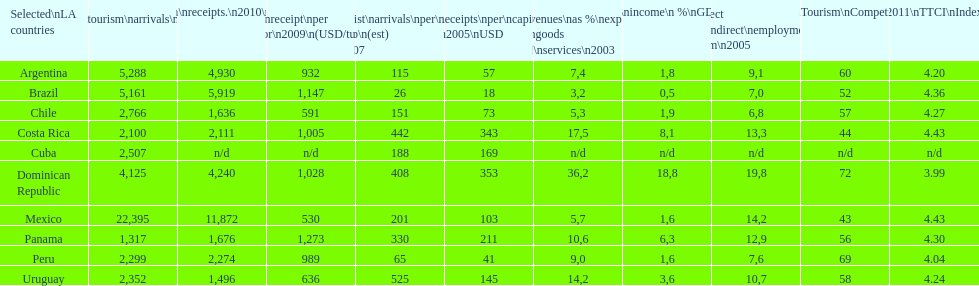Would you mind parsing the complete table? {'header': ['Selected\\nLA countries', 'Internl.\\ntourism\\narrivals\\n2010\\n(x 1000)', 'Internl.\\ntourism\\nreceipts.\\n2010\\n(USD\\n(x1000)', 'Avg\\nreceipt\\nper visitor\\n2009\\n(USD/turista)', 'Tourist\\narrivals\\nper\\n1000 inhab\\n(est) \\n2007', 'Receipts\\nper\\ncapita \\n2005\\nUSD', 'Revenues\\nas\xa0%\\nexports of\\ngoods and\\nservices\\n2003', 'Tourism\\nincome\\n\xa0%\\nGDP\\n2003', '% Direct and\\nindirect\\nemployment\\nin tourism\\n2005', 'World\\nranking\\nTourism\\nCompetitiv.\\nTTCI\\n2011', '2011\\nTTCI\\nIndex'], 'rows': [['Argentina', '5,288', '4,930', '932', '115', '57', '7,4', '1,8', '9,1', '60', '4.20'], ['Brazil', '5,161', '5,919', '1,147', '26', '18', '3,2', '0,5', '7,0', '52', '4.36'], ['Chile', '2,766', '1,636', '591', '151', '73', '5,3', '1,9', '6,8', '57', '4.27'], ['Costa Rica', '2,100', '2,111', '1,005', '442', '343', '17,5', '8,1', '13,3', '44', '4.43'], ['Cuba', '2,507', 'n/d', 'n/d', '188', '169', 'n/d', 'n/d', 'n/d', 'n/d', 'n/d'], ['Dominican Republic', '4,125', '4,240', '1,028', '408', '353', '36,2', '18,8', '19,8', '72', '3.99'], ['Mexico', '22,395', '11,872', '530', '201', '103', '5,7', '1,6', '14,2', '43', '4.43'], ['Panama', '1,317', '1,676', '1,273', '330', '211', '10,6', '6,3', '12,9', '56', '4.30'], ['Peru', '2,299', '2,274', '989', '65', '41', '9,0', '1,6', '7,6', '69', '4.04'], ['Uruguay', '2,352', '1,496', '636', '525', '145', '14,2', '3,6', '10,7', '58', '4.24']]} How many dollars on average did brazil receive per tourist in 2009? 1,147. 